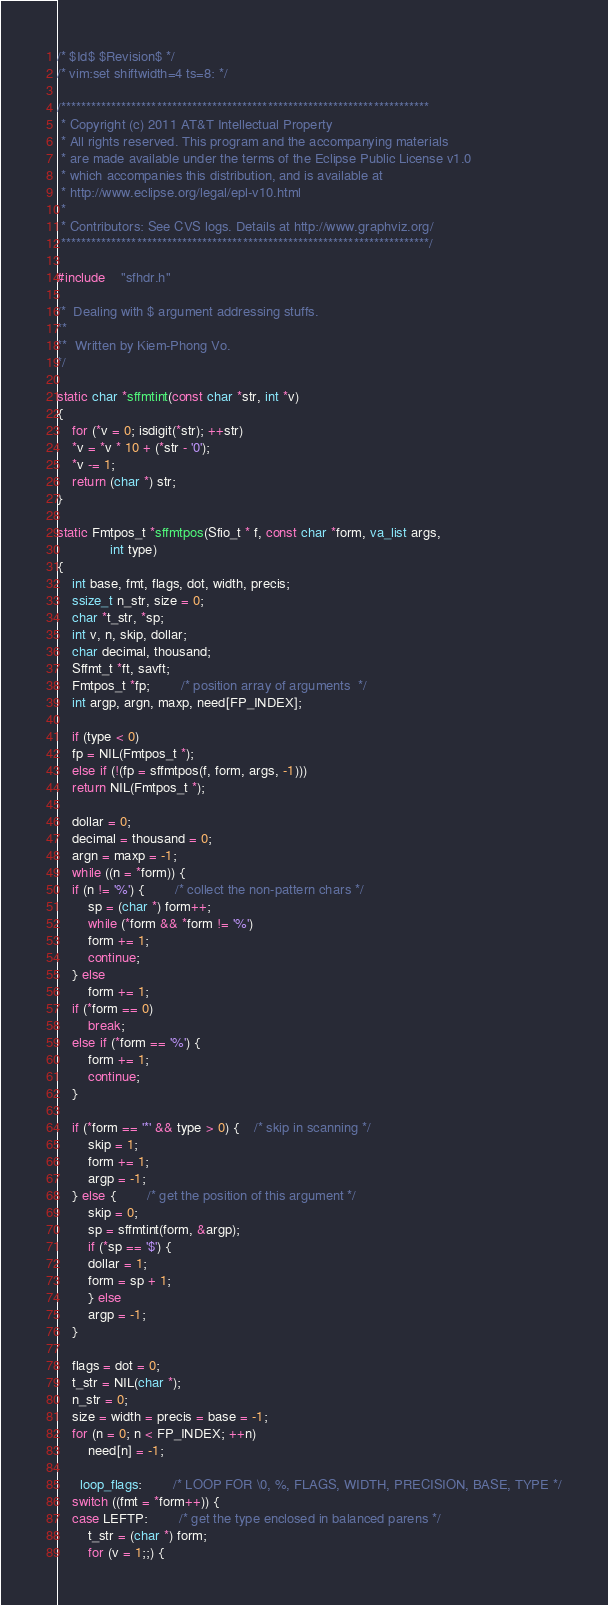Convert code to text. <code><loc_0><loc_0><loc_500><loc_500><_C_>/* $Id$ $Revision$ */
/* vim:set shiftwidth=4 ts=8: */

/*************************************************************************
 * Copyright (c) 2011 AT&T Intellectual Property 
 * All rights reserved. This program and the accompanying materials
 * are made available under the terms of the Eclipse Public License v1.0
 * which accompanies this distribution, and is available at
 * http://www.eclipse.org/legal/epl-v10.html
 *
 * Contributors: See CVS logs. Details at http://www.graphviz.org/
 *************************************************************************/

#include	"sfhdr.h"

/*	Dealing with $ argument addressing stuffs.
**
**	Written by Kiem-Phong Vo.
*/

static char *sffmtint(const char *str, int *v)
{
    for (*v = 0; isdigit(*str); ++str)
	*v = *v * 10 + (*str - '0');
    *v -= 1;
    return (char *) str;
}

static Fmtpos_t *sffmtpos(Sfio_t * f, const char *form, va_list args,
			  int type)
{
    int base, fmt, flags, dot, width, precis;
    ssize_t n_str, size = 0;
    char *t_str, *sp;
    int v, n, skip, dollar;
    char decimal, thousand;
    Sffmt_t *ft, savft;
    Fmtpos_t *fp;		/* position array of arguments  */
    int argp, argn, maxp, need[FP_INDEX];

    if (type < 0)
	fp = NIL(Fmtpos_t *);
    else if (!(fp = sffmtpos(f, form, args, -1)))
	return NIL(Fmtpos_t *);

    dollar = 0;
    decimal = thousand = 0;
    argn = maxp = -1;
    while ((n = *form)) {
	if (n != '%') {		/* collect the non-pattern chars */
	    sp = (char *) form++;
	    while (*form && *form != '%')
		form += 1;
	    continue;
	} else
	    form += 1;
	if (*form == 0)
	    break;
	else if (*form == '%') {
	    form += 1;
	    continue;
	}

	if (*form == '*' && type > 0) {	/* skip in scanning */
	    skip = 1;
	    form += 1;
	    argp = -1;
	} else {		/* get the position of this argument */
	    skip = 0;
	    sp = sffmtint(form, &argp);
	    if (*sp == '$') {
		dollar = 1;
		form = sp + 1;
	    } else
		argp = -1;
	}

	flags = dot = 0;
	t_str = NIL(char *);
	n_str = 0;
	size = width = precis = base = -1;
	for (n = 0; n < FP_INDEX; ++n)
	    need[n] = -1;

      loop_flags:		/* LOOP FOR \0, %, FLAGS, WIDTH, PRECISION, BASE, TYPE */
	switch ((fmt = *form++)) {
	case LEFTP:		/* get the type enclosed in balanced parens */
	    t_str = (char *) form;
	    for (v = 1;;) {</code> 